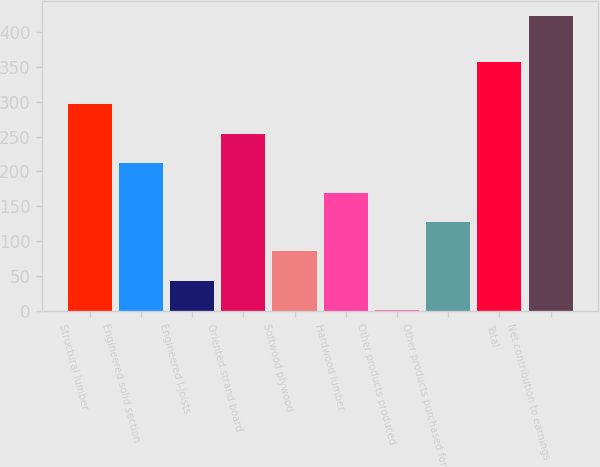Convert chart to OTSL. <chart><loc_0><loc_0><loc_500><loc_500><bar_chart><fcel>Structural lumber<fcel>Engineered solid section<fcel>Engineered I-joists<fcel>Oriented strand board<fcel>Softwood plywood<fcel>Hardwood lumber<fcel>Other products produced<fcel>Other products purchased for<fcel>Total<fcel>Net contribution to earnings<nl><fcel>296.4<fcel>212<fcel>43.2<fcel>254.2<fcel>85.4<fcel>169.8<fcel>1<fcel>127.6<fcel>357<fcel>423<nl></chart> 